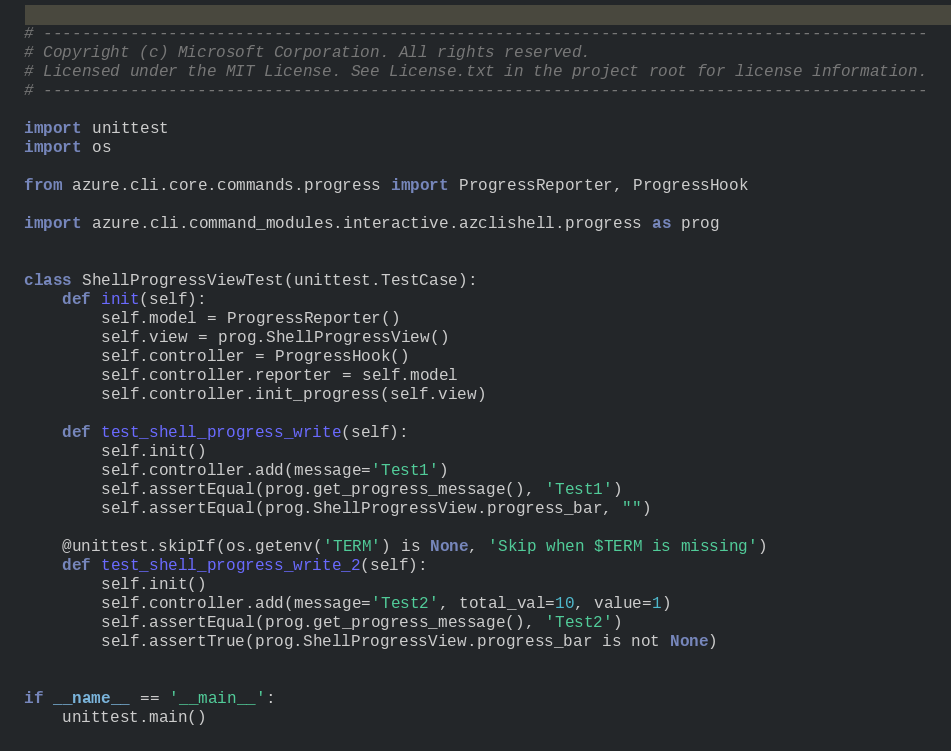<code> <loc_0><loc_0><loc_500><loc_500><_Python_># --------------------------------------------------------------------------------------------
# Copyright (c) Microsoft Corporation. All rights reserved.
# Licensed under the MIT License. See License.txt in the project root for license information.
# --------------------------------------------------------------------------------------------

import unittest
import os

from azure.cli.core.commands.progress import ProgressReporter, ProgressHook

import azure.cli.command_modules.interactive.azclishell.progress as prog


class ShellProgressViewTest(unittest.TestCase):
    def init(self):
        self.model = ProgressReporter()
        self.view = prog.ShellProgressView()
        self.controller = ProgressHook()
        self.controller.reporter = self.model
        self.controller.init_progress(self.view)

    def test_shell_progress_write(self):
        self.init()
        self.controller.add(message='Test1')
        self.assertEqual(prog.get_progress_message(), 'Test1')
        self.assertEqual(prog.ShellProgressView.progress_bar, "")

    @unittest.skipIf(os.getenv('TERM') is None, 'Skip when $TERM is missing')
    def test_shell_progress_write_2(self):
        self.init()
        self.controller.add(message='Test2', total_val=10, value=1)
        self.assertEqual(prog.get_progress_message(), 'Test2')
        self.assertTrue(prog.ShellProgressView.progress_bar is not None)


if __name__ == '__main__':
    unittest.main()
</code> 